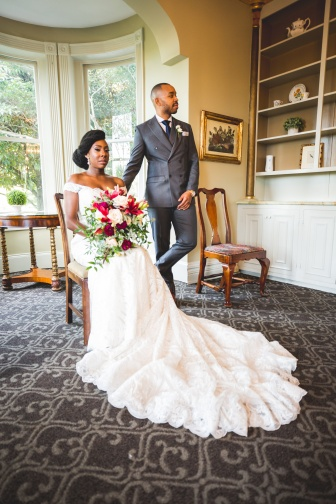How does the design of the room complement the wedding aesthetic? The room's design, with its elegant simplicity, complements the wedding's traditional aesthetic beautifully. The large window provides ample natural light, which highlights the refined aspects of the bride's dress and the decor. The white walls maintain a neutral but classic backdrop, allowing the vibrant colors of the bouquet and the dark tones of the groom's suit to stand out. Additionally, the placement of minimalistic decor like the vase and art piece adds a cultured touch without overpowering the couple's presence. 